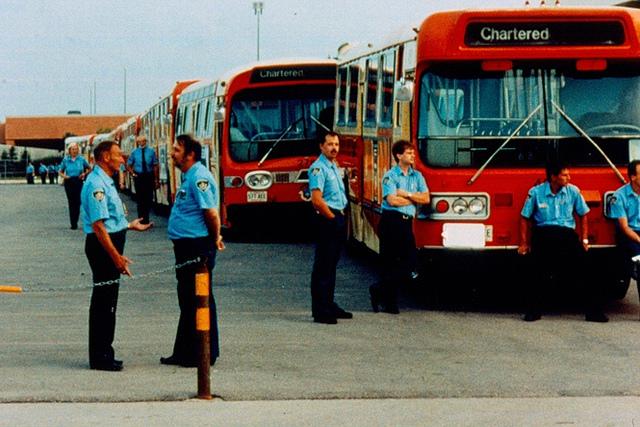What is the occupation of these men?
Concise answer only. Bus drivers. Are all of the men standing?
Give a very brief answer. No. How many people are men?
Give a very brief answer. 7. 